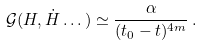Convert formula to latex. <formula><loc_0><loc_0><loc_500><loc_500>\mathcal { G } ( H , \dot { H } \dots ) \simeq \frac { \alpha } { ( t _ { 0 } - t ) ^ { 4 m } } \, .</formula> 